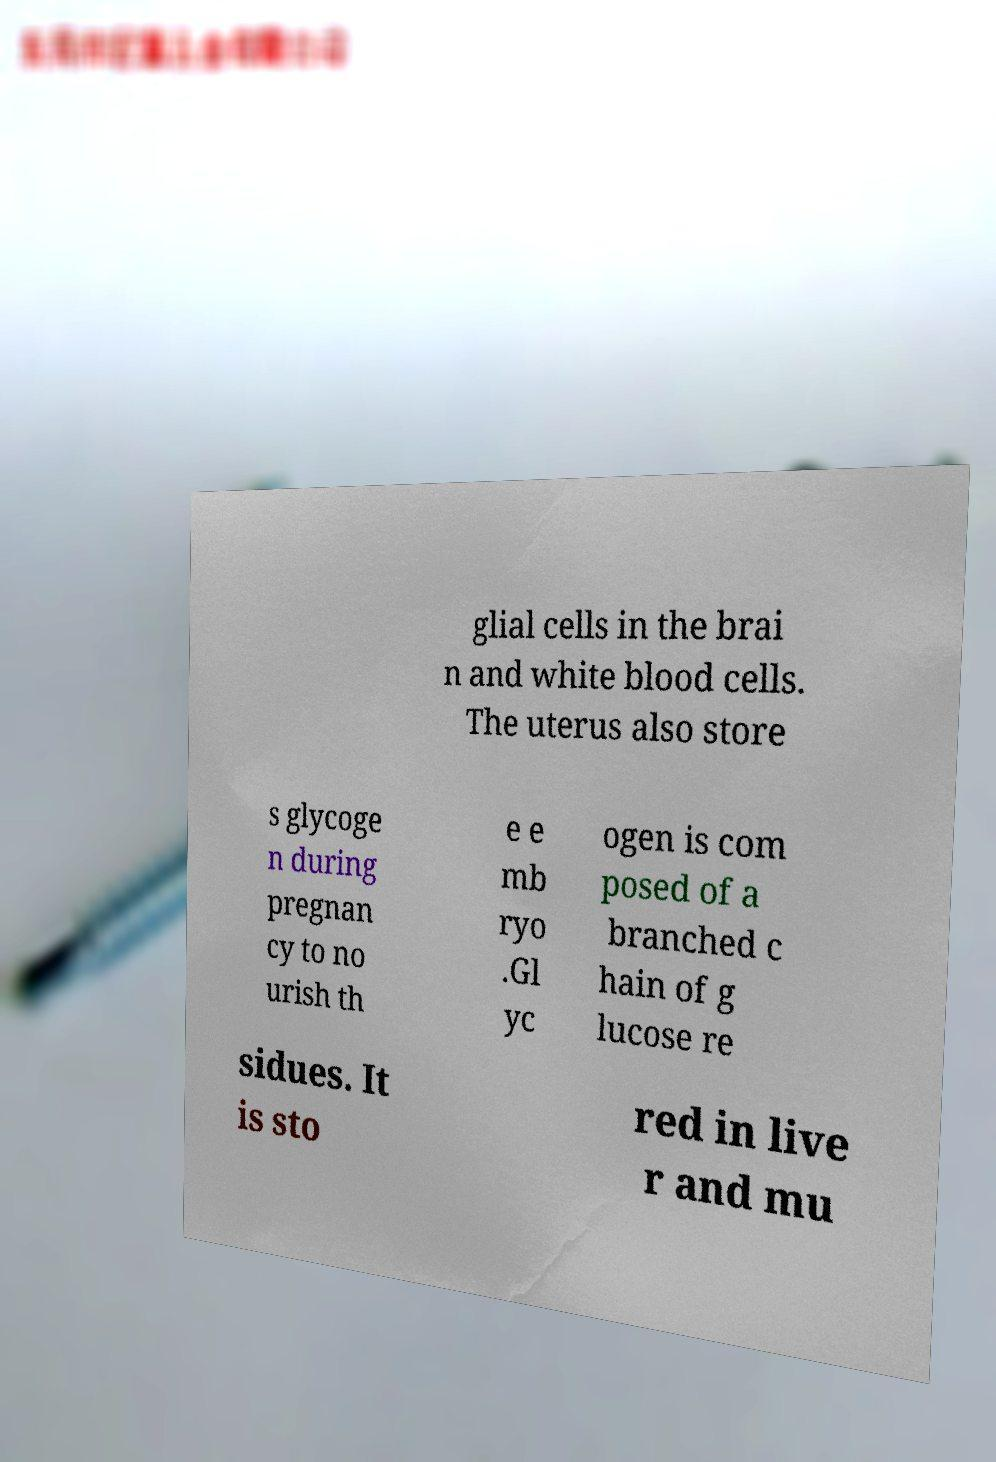I need the written content from this picture converted into text. Can you do that? glial cells in the brai n and white blood cells. The uterus also store s glycoge n during pregnan cy to no urish th e e mb ryo .Gl yc ogen is com posed of a branched c hain of g lucose re sidues. It is sto red in live r and mu 